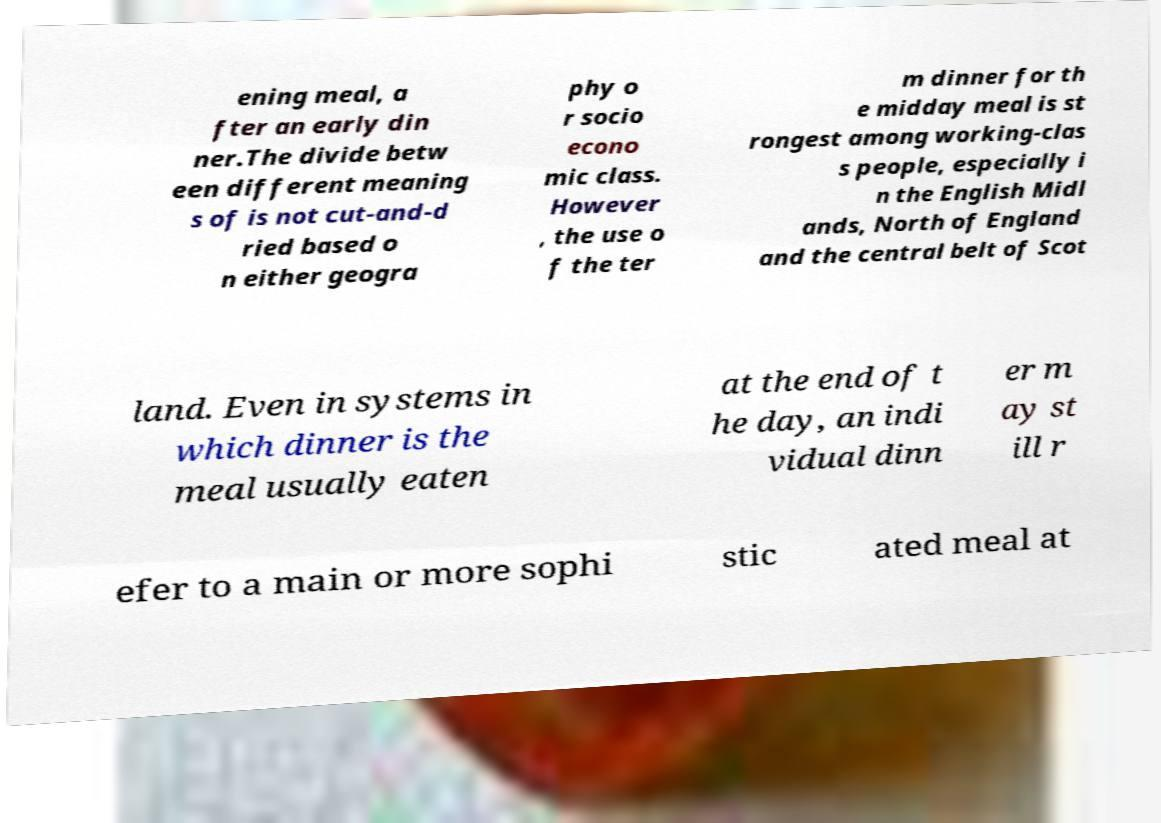Can you read and provide the text displayed in the image?This photo seems to have some interesting text. Can you extract and type it out for me? ening meal, a fter an early din ner.The divide betw een different meaning s of is not cut-and-d ried based o n either geogra phy o r socio econo mic class. However , the use o f the ter m dinner for th e midday meal is st rongest among working-clas s people, especially i n the English Midl ands, North of England and the central belt of Scot land. Even in systems in which dinner is the meal usually eaten at the end of t he day, an indi vidual dinn er m ay st ill r efer to a main or more sophi stic ated meal at 